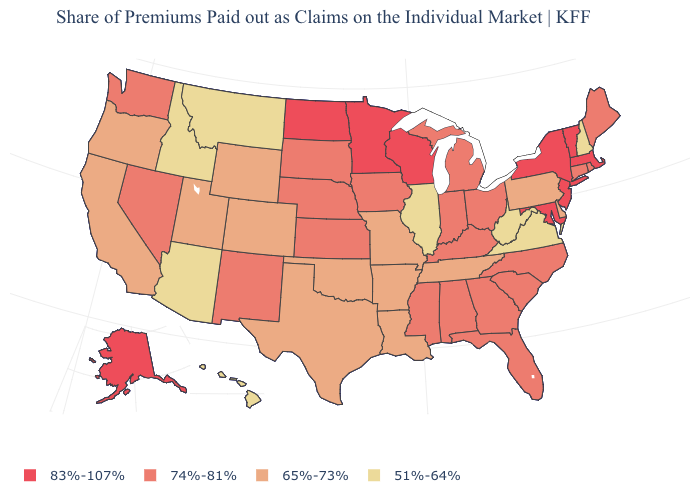What is the lowest value in states that border Pennsylvania?
Keep it brief. 51%-64%. Does the map have missing data?
Quick response, please. No. What is the value of Vermont?
Be succinct. 83%-107%. Is the legend a continuous bar?
Quick response, please. No. Name the states that have a value in the range 65%-73%?
Answer briefly. Arkansas, California, Colorado, Delaware, Louisiana, Missouri, Oklahoma, Oregon, Pennsylvania, Tennessee, Texas, Utah, Wyoming. Name the states that have a value in the range 51%-64%?
Concise answer only. Arizona, Hawaii, Idaho, Illinois, Montana, New Hampshire, Virginia, West Virginia. Among the states that border West Virginia , which have the lowest value?
Give a very brief answer. Virginia. Does Montana have a lower value than Idaho?
Write a very short answer. No. Name the states that have a value in the range 74%-81%?
Answer briefly. Alabama, Connecticut, Florida, Georgia, Indiana, Iowa, Kansas, Kentucky, Maine, Michigan, Mississippi, Nebraska, Nevada, New Mexico, North Carolina, Ohio, Rhode Island, South Carolina, South Dakota, Washington. Name the states that have a value in the range 83%-107%?
Concise answer only. Alaska, Maryland, Massachusetts, Minnesota, New Jersey, New York, North Dakota, Vermont, Wisconsin. Name the states that have a value in the range 65%-73%?
Give a very brief answer. Arkansas, California, Colorado, Delaware, Louisiana, Missouri, Oklahoma, Oregon, Pennsylvania, Tennessee, Texas, Utah, Wyoming. Does Rhode Island have the highest value in the Northeast?
Give a very brief answer. No. Does the map have missing data?
Answer briefly. No. Among the states that border South Dakota , which have the highest value?
Concise answer only. Minnesota, North Dakota. 